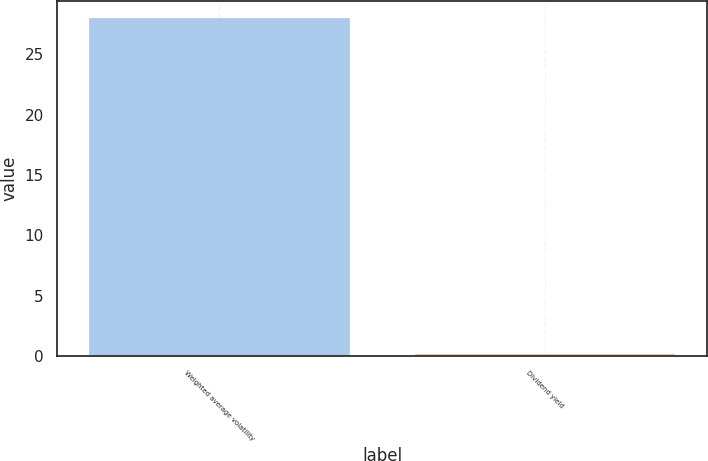Convert chart. <chart><loc_0><loc_0><loc_500><loc_500><bar_chart><fcel>Weighted average volatility<fcel>Dividend yield<nl><fcel>28<fcel>0.2<nl></chart> 